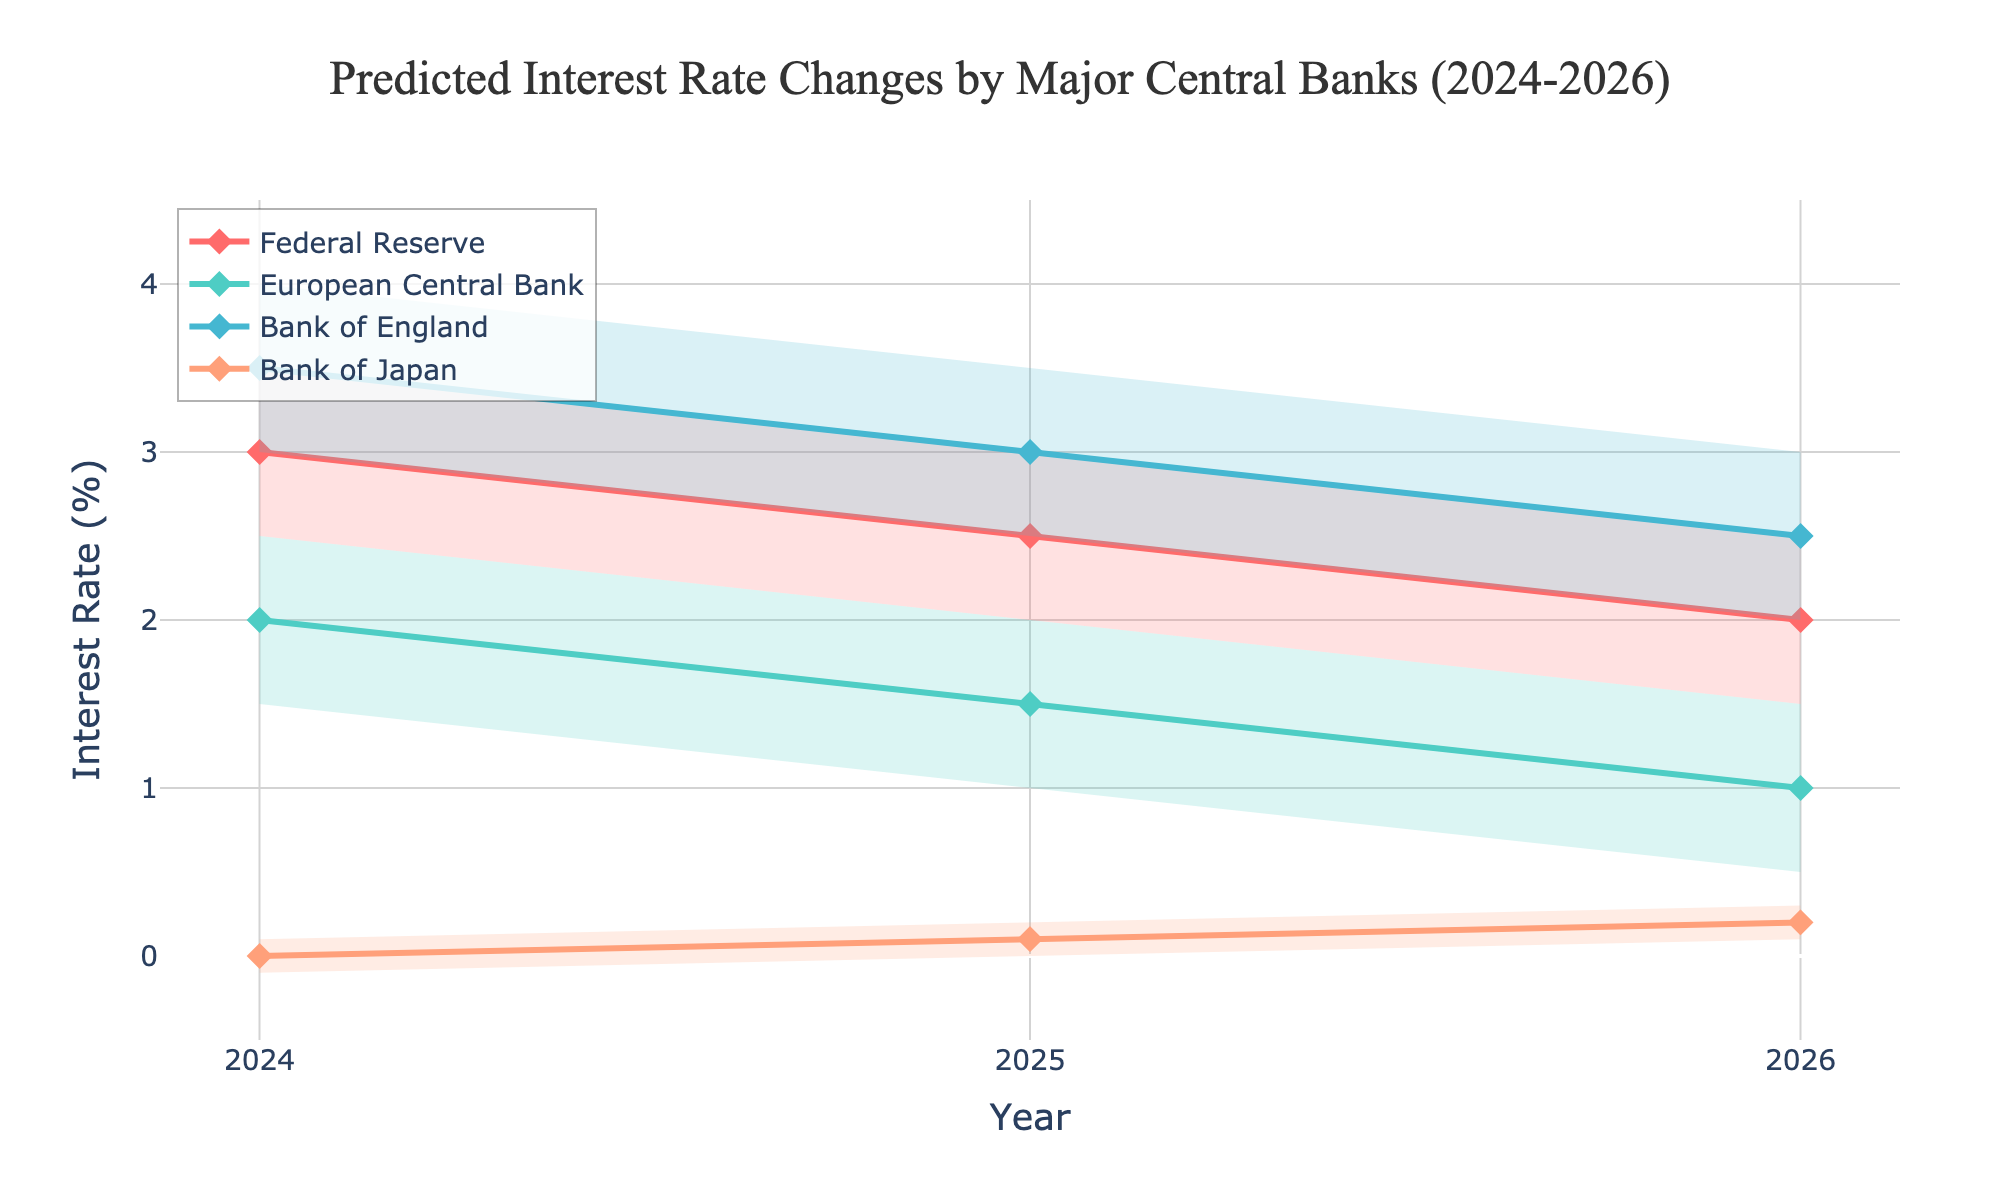What are the central banks represented in the chart? The chart shows data for four major central banks. These are the Federal Reserve, European Central Bank, Bank of England, and Bank of Japan.
Answer: Federal Reserve, European Central Bank, Bank of England, Bank of Japan How does the predicted central estimate interest rate for the Federal Reserve change from 2024 to 2026? The central estimate interest rate for the Federal Reserve is 3.0% in 2024, 2.5% in 2025, and 2.0% in 2026.
Answer: Decreases from 3.0% to 2.0% What is the range of the predicted interest rate for the Bank of Japan in 2025? For the Bank of Japan in 2025, the low estimate is 0.0% and the high estimate is 0.2%. The range is the difference between these values.
Answer: 0.2% Which central bank has the highest central estimate for 2026? The Bank of England has the highest central estimate for 2026 at 2.5%.
Answer: Bank of England Compare the high estimates of the Federal Reserve and the European Central Bank for 2024. Which is higher and by how much? The high estimate for the Federal Reserve in 2024 is 3.5%, and for the European Central Bank, it is 2.5%. The Federal Reserve’s high estimate is higher by 1.0%.
Answer: Federal Reserve by 1.0% What is the trend in the central estimate interest rate for the European Central Bank from 2024 to 2026? The central estimate for the European Central Bank decreases each year: 2.0% in 2024, 1.5% in 2025, and 1.0% in 2026.
Answer: Decreasing trend Which central bank shows the least variability in its predicted interest rates for 2025? Variability can be assessed by the difference between the high and low estimates. The Bank of Japan has a range of 0.2% (0.2% - 0.0%) in 2025, which is the smallest range among the central banks.
Answer: Bank of Japan What is the approximate average central estimate interest rate for all the central banks in 2024? Calculate the average of the central estimates for 2024: (3.0% + 2.0% + 3.5% + 0.0%) / 4.
Answer: 2.125% Which central bank's predicted central estimate interest rate changes the most between 2024 and 2026? Calculate the difference between the central estimates in 2024 and 2026 for each bank. The Federal Reserve changes by 1.0% (3.0% to 2.0%), the European Central Bank by 1.0% (2.0% to 1.0%), the Bank of England by 1.0% (3.5% to 2.5%), and the Bank of Japan by 0.2% (0.0% to 0.2%). The largest change is 1.0%.
Answer: All except Bank of Japan (1.0%) Is there any year where all central banks' central estimates are increasing, decreasing, or constant? Analyze each year's data. In 2025 and 2026, all central banks' central estimates are decreasing from their previous year's estimate.
Answer: Decreasing in 2025 and 2026 